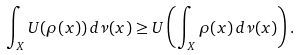<formula> <loc_0><loc_0><loc_500><loc_500>\int _ { X } U ( \rho ( x ) ) \, d \nu ( x ) \geq U \left ( \int _ { X } \rho ( x ) \, d \nu ( x ) \right ) .</formula> 